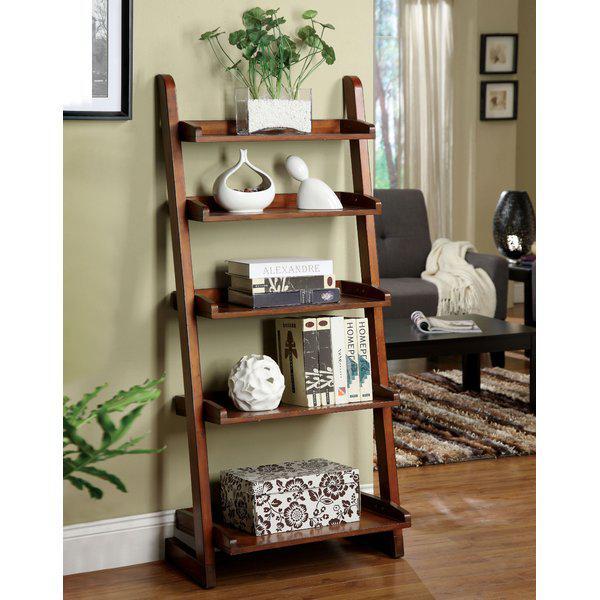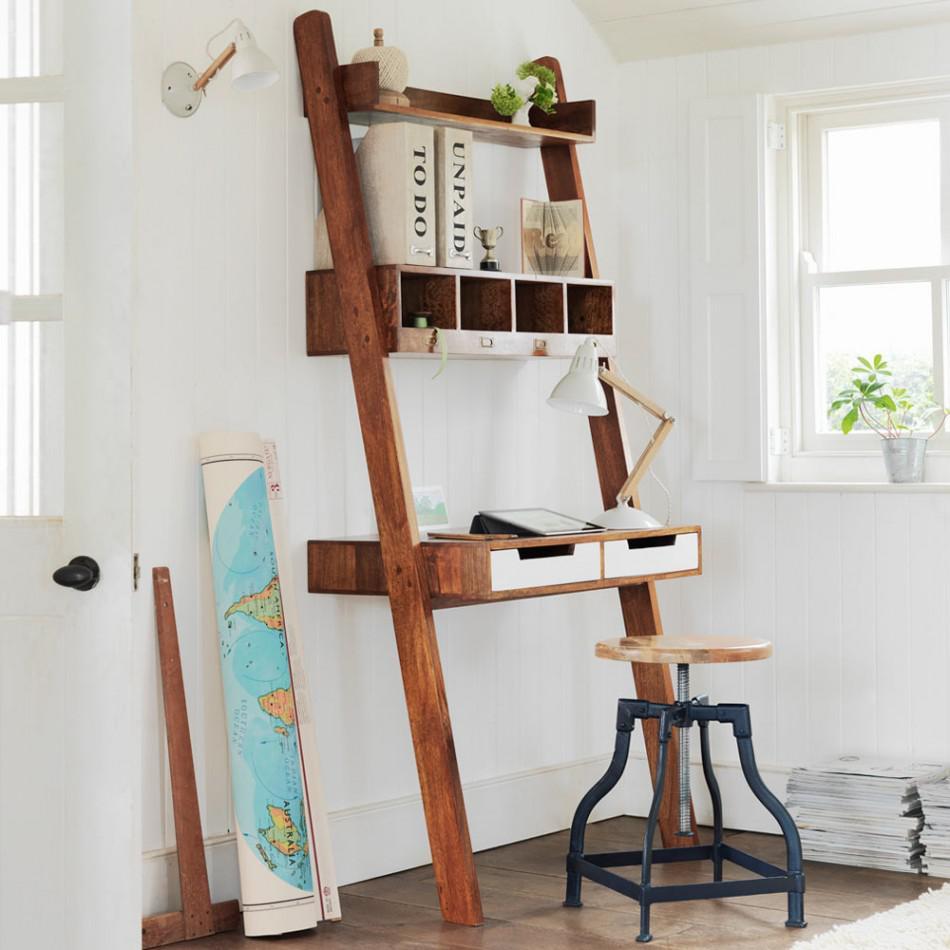The first image is the image on the left, the second image is the image on the right. For the images displayed, is the sentence "The left image shows a non-white shelf unit that leans against a wall like a ladder and has three vertical sections, with a small desk in the center with a chair pulled up to it." factually correct? Answer yes or no. No. 